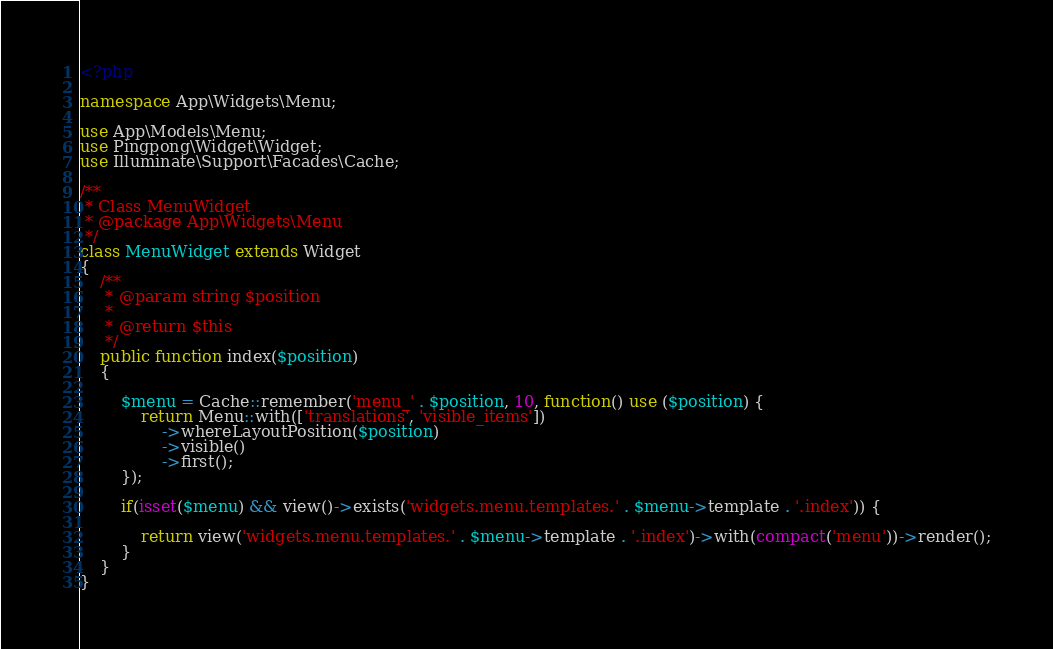Convert code to text. <code><loc_0><loc_0><loc_500><loc_500><_PHP_><?php

namespace App\Widgets\Menu;

use App\Models\Menu;
use Pingpong\Widget\Widget;
use Illuminate\Support\Facades\Cache;

/**
 * Class MenuWidget
 * @package App\Widgets\Menu
 */
class MenuWidget extends Widget
{
    /**
     * @param string $position
     *
     * @return $this
     */
    public function index($position)
    {

        $menu = Cache::remember('menu_' . $position, 10, function() use ($position) {
            return Menu::with(['translations', 'visible_items'])
                ->whereLayoutPosition($position)
                ->visible()
                ->first();
        });

        if(isset($menu) && view()->exists('widgets.menu.templates.' . $menu->template . '.index')) {

            return view('widgets.menu.templates.' . $menu->template . '.index')->with(compact('menu'))->render();
        }
    }
}</code> 